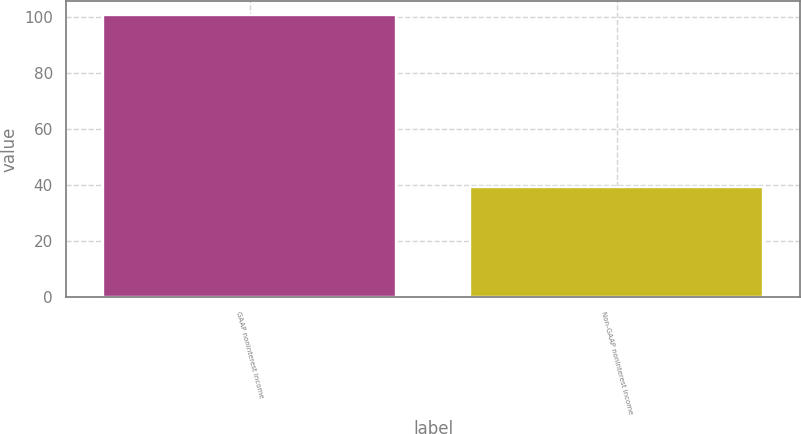<chart> <loc_0><loc_0><loc_500><loc_500><bar_chart><fcel>GAAP noninterest income<fcel>Non-GAAP noninterest income<nl><fcel>100.6<fcel>39.13<nl></chart> 